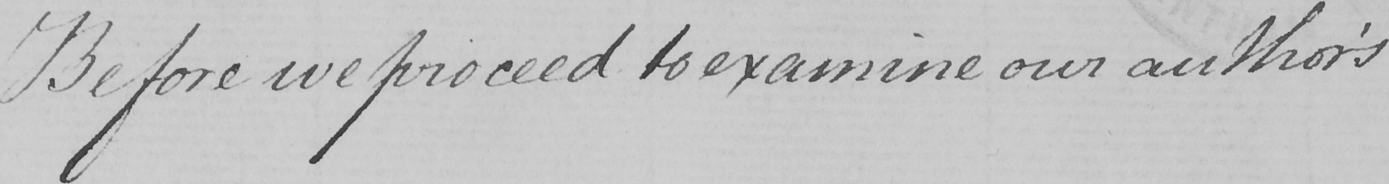Please transcribe the handwritten text in this image. Before we proceed to examine our author ' s 